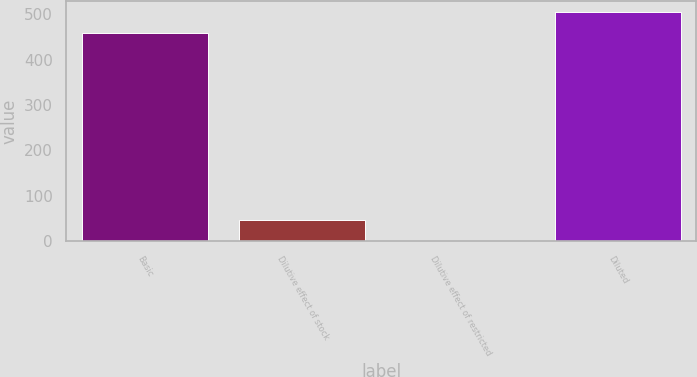Convert chart to OTSL. <chart><loc_0><loc_0><loc_500><loc_500><bar_chart><fcel>Basic<fcel>Dilutive effect of stock<fcel>Dilutive effect of restricted<fcel>Diluted<nl><fcel>458.5<fcel>47.24<fcel>1.2<fcel>504.54<nl></chart> 